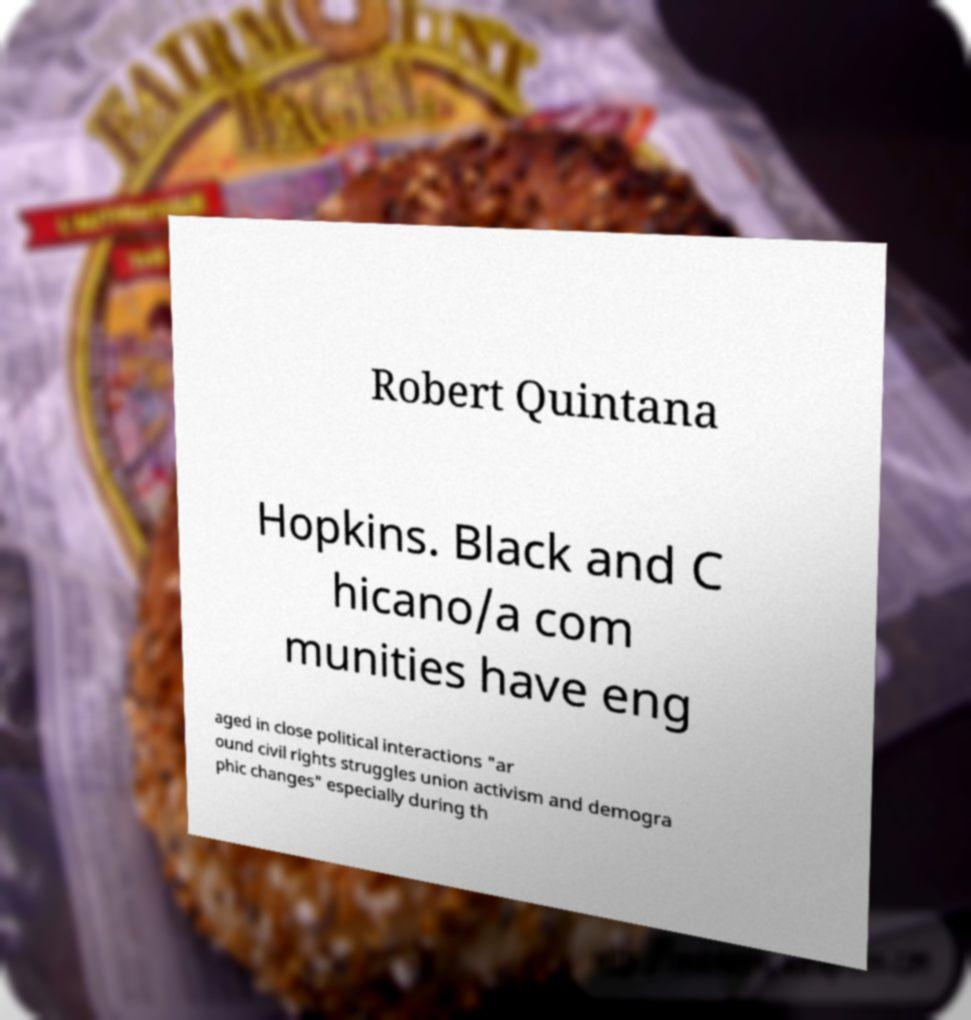I need the written content from this picture converted into text. Can you do that? Robert Quintana Hopkins. Black and C hicano/a com munities have eng aged in close political interactions "ar ound civil rights struggles union activism and demogra phic changes" especially during th 